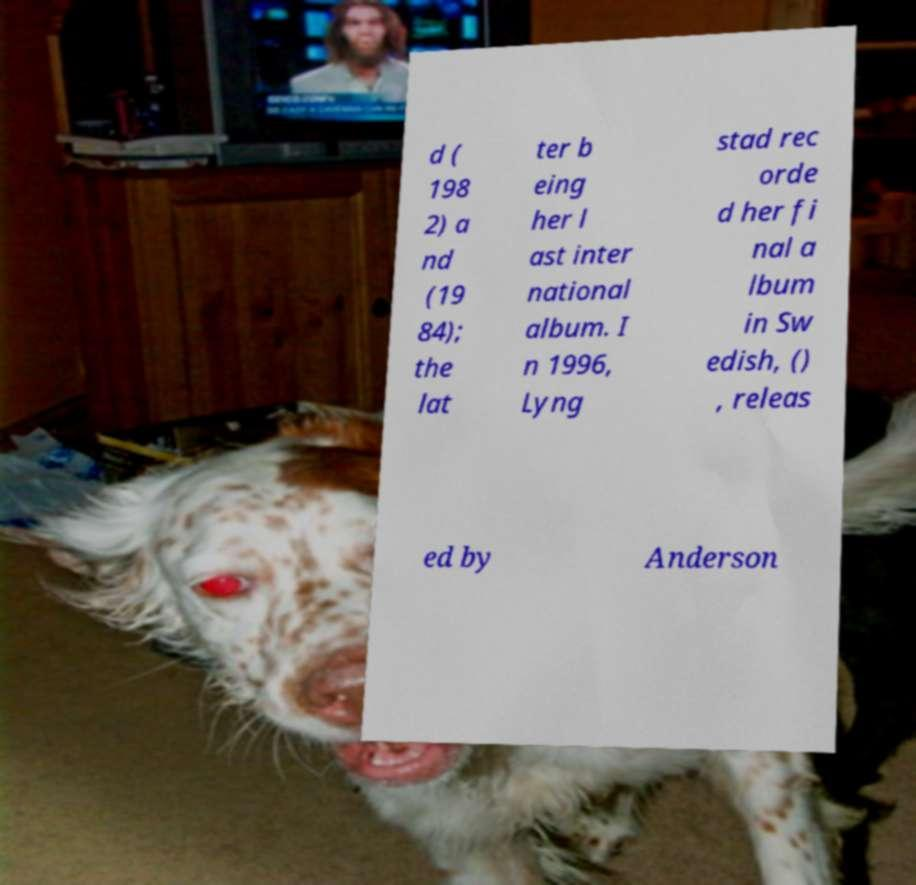There's text embedded in this image that I need extracted. Can you transcribe it verbatim? d ( 198 2) a nd (19 84); the lat ter b eing her l ast inter national album. I n 1996, Lyng stad rec orde d her fi nal a lbum in Sw edish, () , releas ed by Anderson 